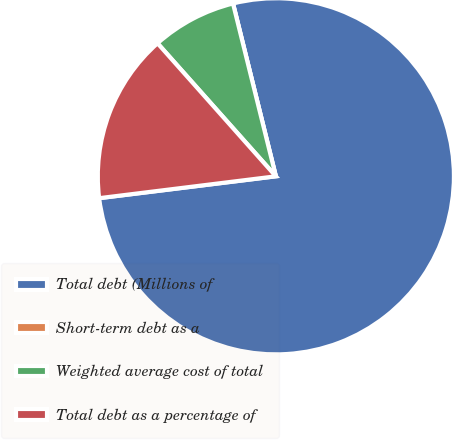Convert chart. <chart><loc_0><loc_0><loc_500><loc_500><pie_chart><fcel>Total debt (Millions of<fcel>Short-term debt as a<fcel>Weighted average cost of total<fcel>Total debt as a percentage of<nl><fcel>76.91%<fcel>0.0%<fcel>7.7%<fcel>15.39%<nl></chart> 